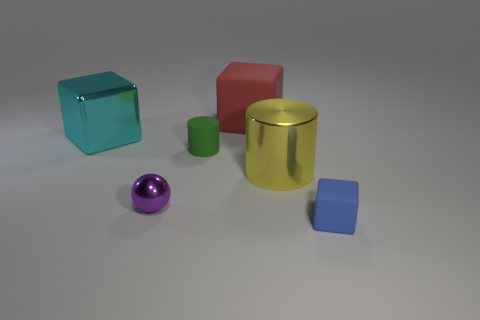Are there any red matte cubes that have the same size as the cyan thing?
Keep it short and to the point. Yes. Are the small sphere and the big object that is on the right side of the big red object made of the same material?
Ensure brevity in your answer.  Yes. Are there more balls than big objects?
Offer a very short reply. No. How many spheres are small brown rubber objects or yellow metallic objects?
Offer a very short reply. 0. The big rubber block has what color?
Your answer should be compact. Red. There is a object that is behind the cyan thing; is its size the same as the thing in front of the purple shiny thing?
Keep it short and to the point. No. Is the number of brown metallic blocks less than the number of yellow shiny things?
Keep it short and to the point. Yes. What number of big blocks are to the left of the big red matte object?
Your answer should be compact. 1. What material is the yellow cylinder?
Provide a short and direct response. Metal. Are there fewer big yellow objects on the right side of the cyan metal object than big red balls?
Make the answer very short. No. 